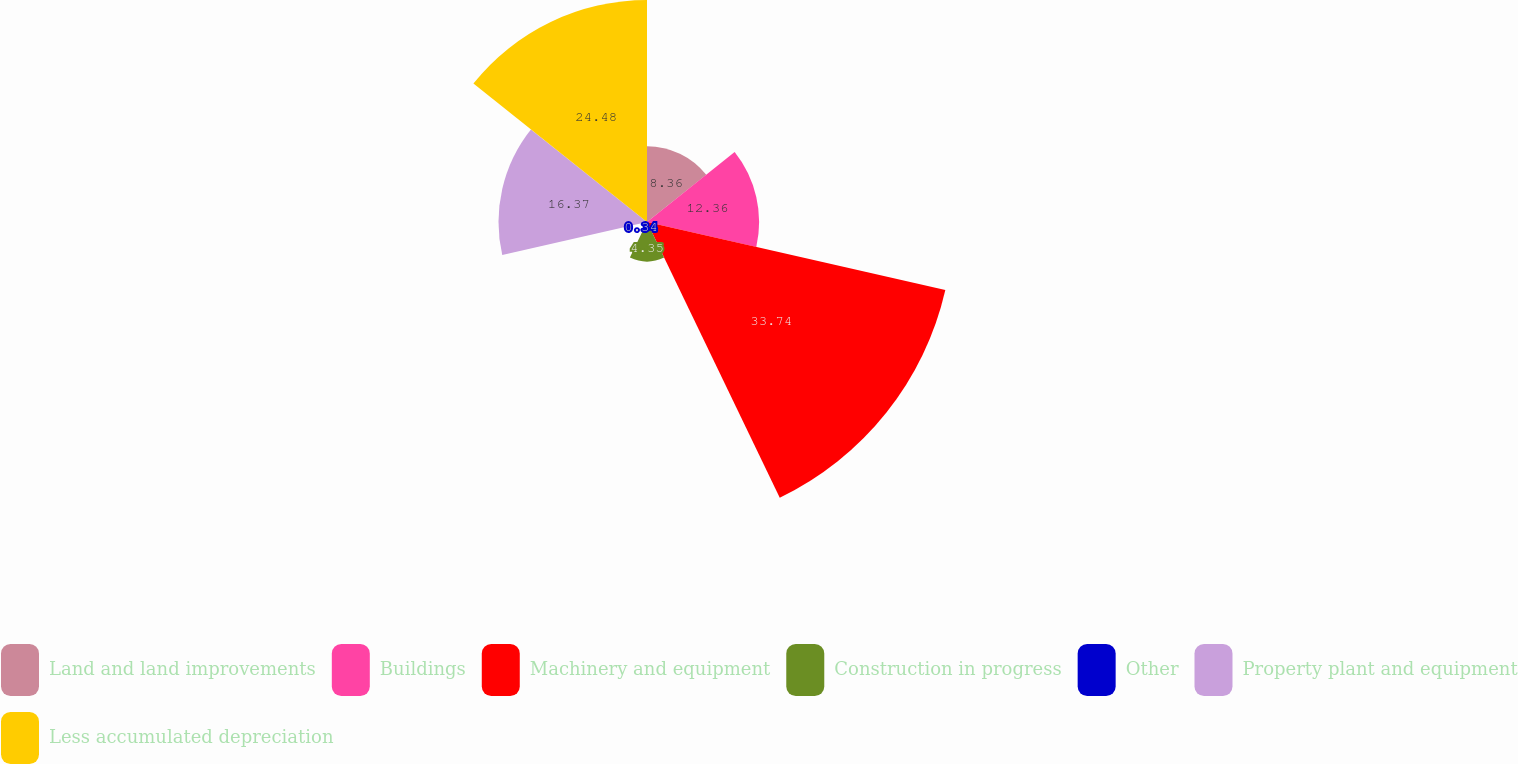Convert chart to OTSL. <chart><loc_0><loc_0><loc_500><loc_500><pie_chart><fcel>Land and land improvements<fcel>Buildings<fcel>Machinery and equipment<fcel>Construction in progress<fcel>Other<fcel>Property plant and equipment<fcel>Less accumulated depreciation<nl><fcel>8.36%<fcel>12.36%<fcel>33.74%<fcel>4.35%<fcel>0.34%<fcel>16.37%<fcel>24.48%<nl></chart> 